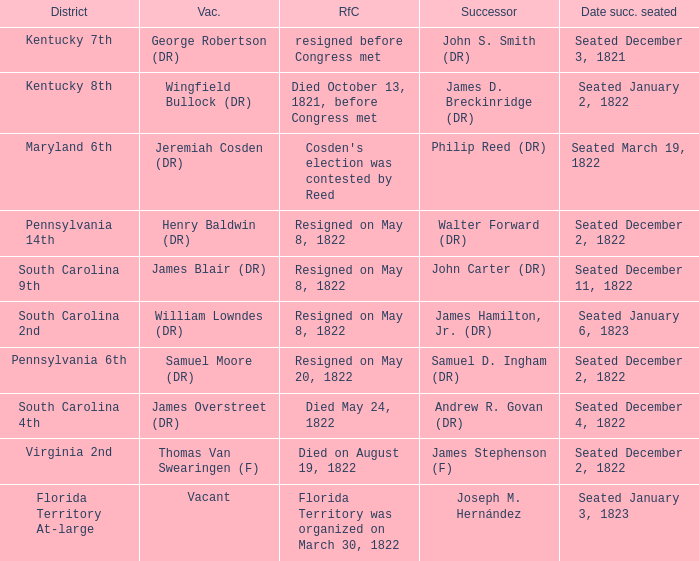Who is the vacator when south carolina 4th is the district? James Overstreet (DR). 